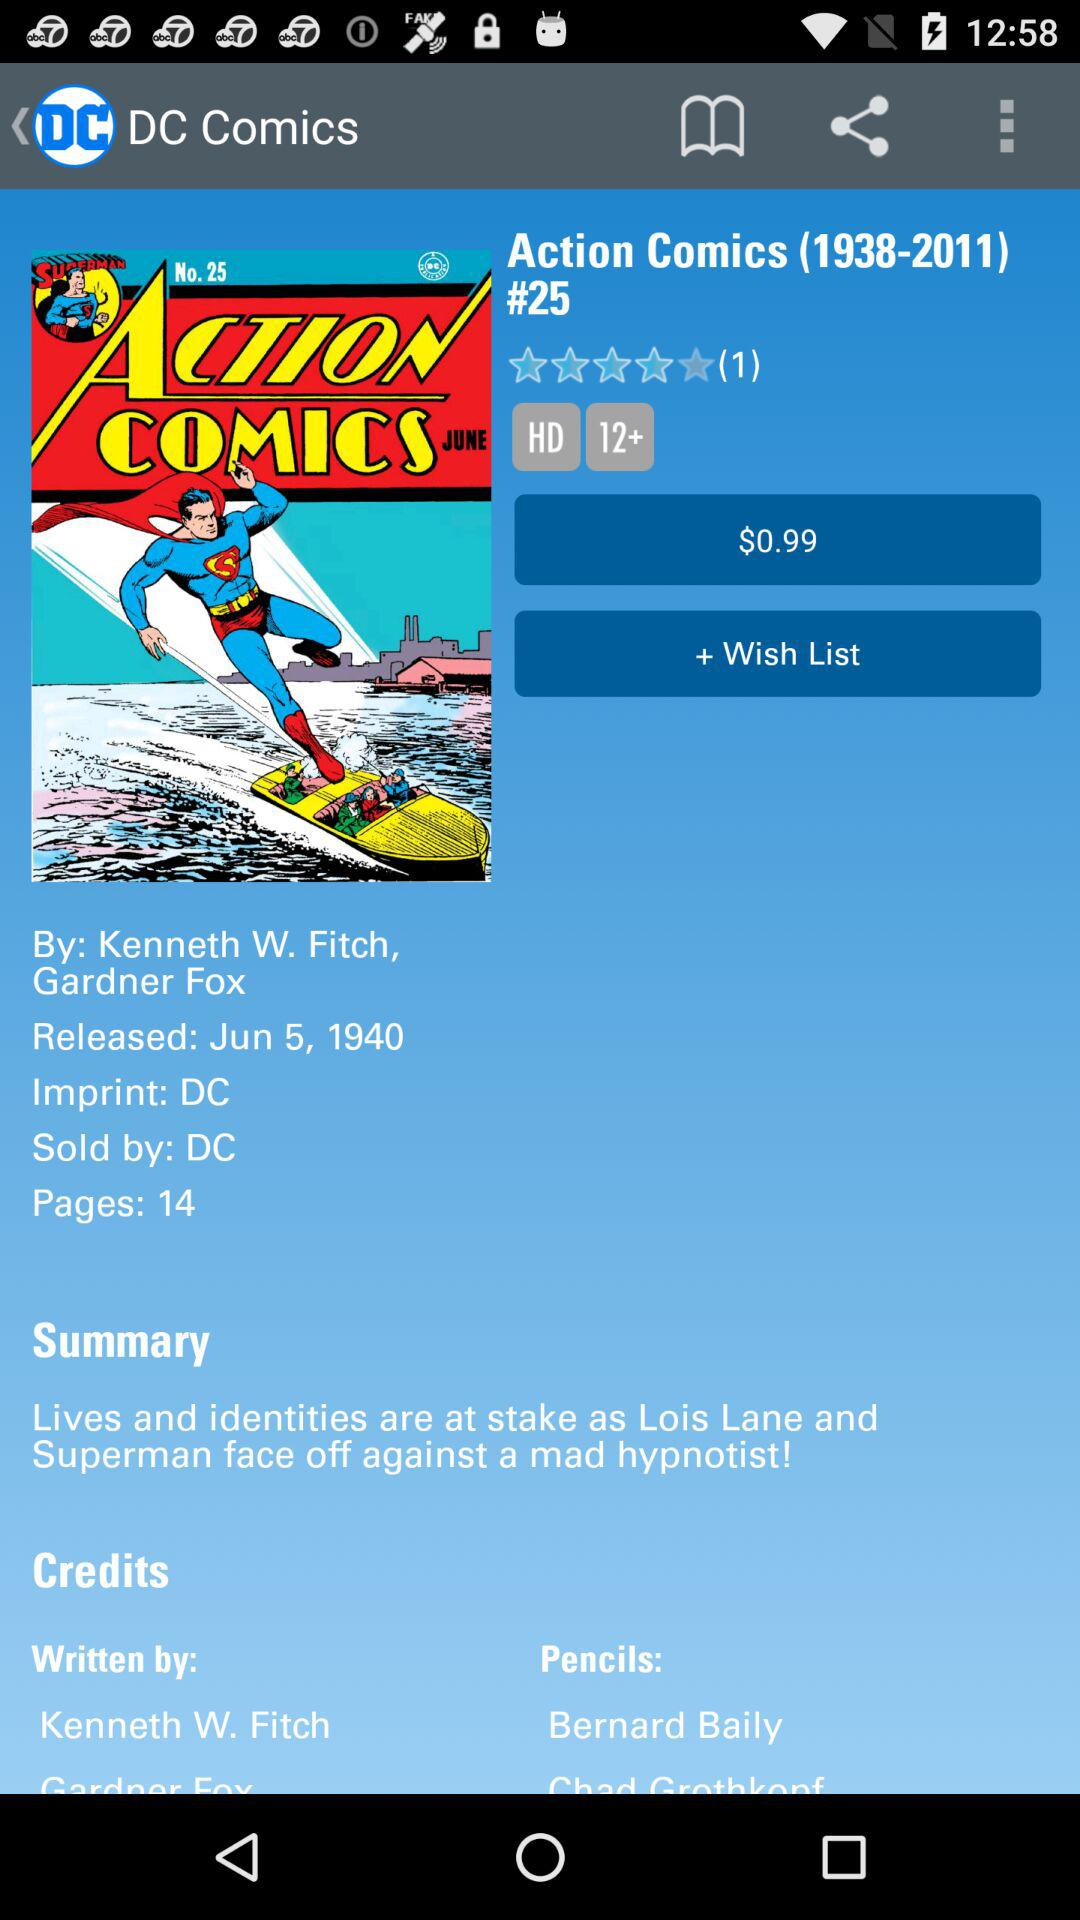What is the cost of the "Action Comics"? The cost of the "Action Comics" is $0.99. 